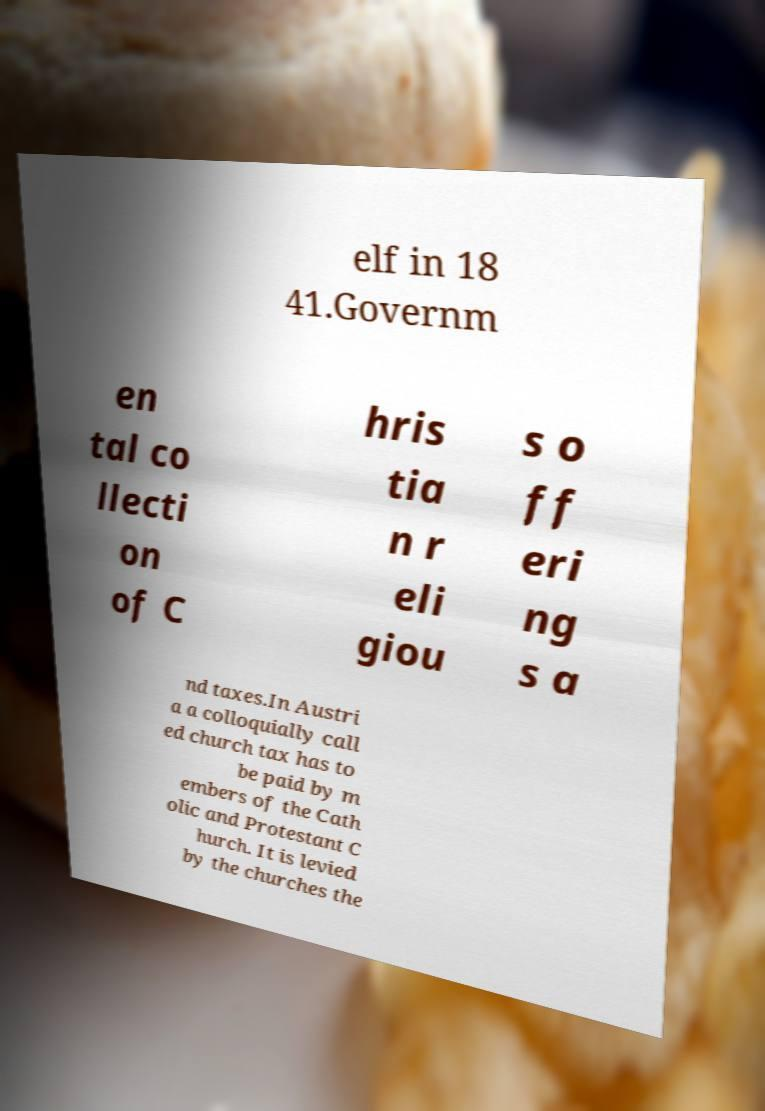I need the written content from this picture converted into text. Can you do that? elf in 18 41.Governm en tal co llecti on of C hris tia n r eli giou s o ff eri ng s a nd taxes.In Austri a a colloquially call ed church tax has to be paid by m embers of the Cath olic and Protestant C hurch. It is levied by the churches the 